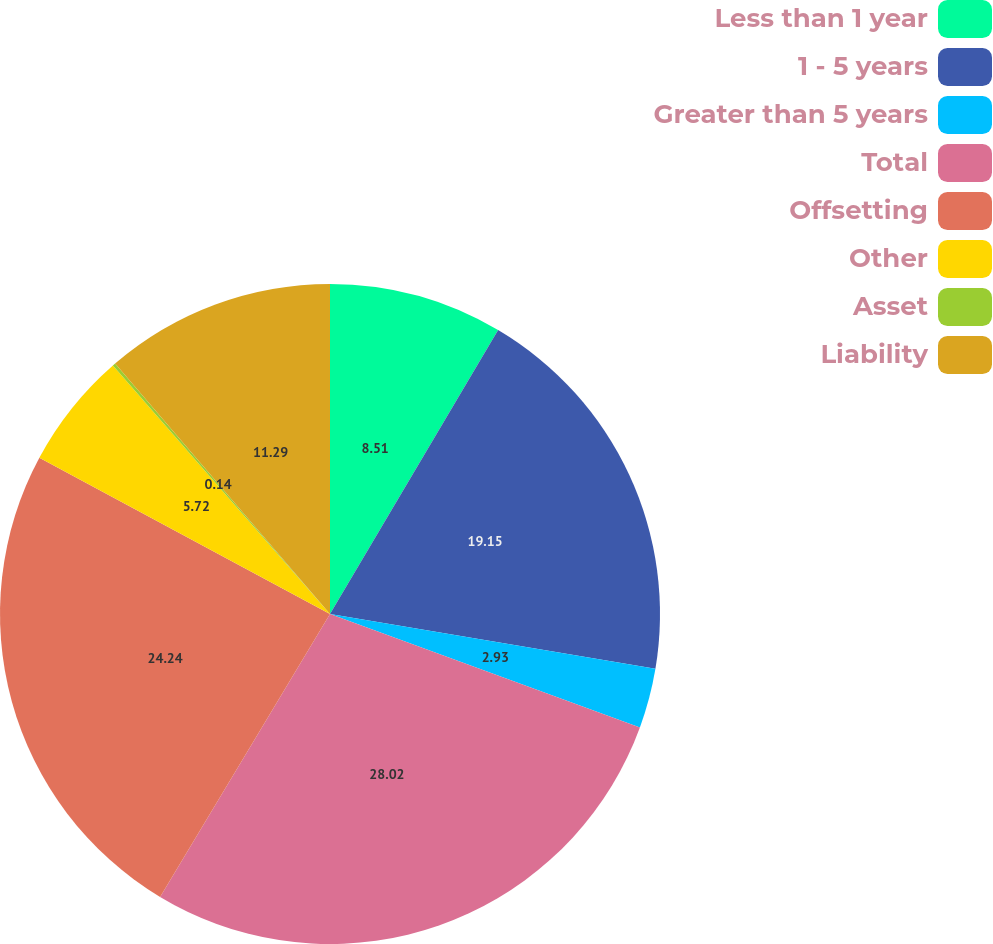Convert chart. <chart><loc_0><loc_0><loc_500><loc_500><pie_chart><fcel>Less than 1 year<fcel>1 - 5 years<fcel>Greater than 5 years<fcel>Total<fcel>Offsetting<fcel>Other<fcel>Asset<fcel>Liability<nl><fcel>8.51%<fcel>19.15%<fcel>2.93%<fcel>28.03%<fcel>24.25%<fcel>5.72%<fcel>0.14%<fcel>11.29%<nl></chart> 